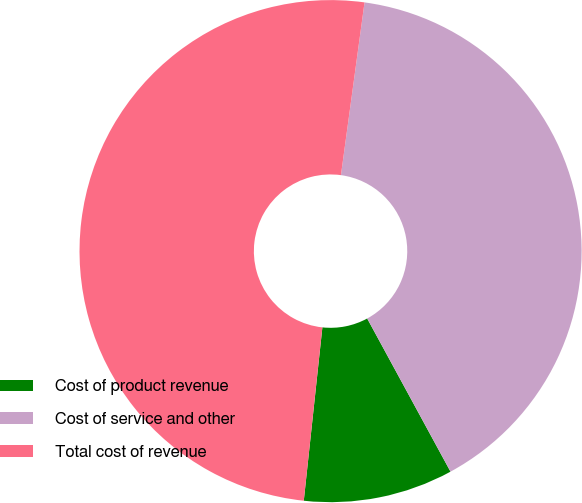Convert chart to OTSL. <chart><loc_0><loc_0><loc_500><loc_500><pie_chart><fcel>Cost of product revenue<fcel>Cost of service and other<fcel>Total cost of revenue<nl><fcel>9.63%<fcel>39.91%<fcel>50.46%<nl></chart> 